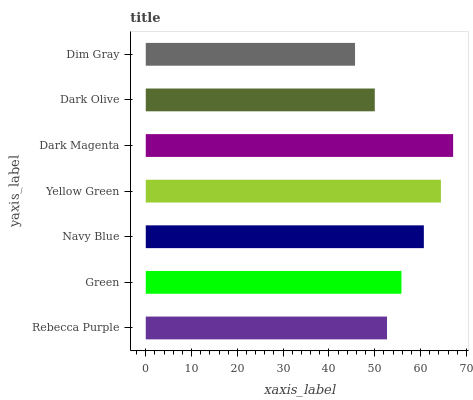Is Dim Gray the minimum?
Answer yes or no. Yes. Is Dark Magenta the maximum?
Answer yes or no. Yes. Is Green the minimum?
Answer yes or no. No. Is Green the maximum?
Answer yes or no. No. Is Green greater than Rebecca Purple?
Answer yes or no. Yes. Is Rebecca Purple less than Green?
Answer yes or no. Yes. Is Rebecca Purple greater than Green?
Answer yes or no. No. Is Green less than Rebecca Purple?
Answer yes or no. No. Is Green the high median?
Answer yes or no. Yes. Is Green the low median?
Answer yes or no. Yes. Is Dim Gray the high median?
Answer yes or no. No. Is Dim Gray the low median?
Answer yes or no. No. 